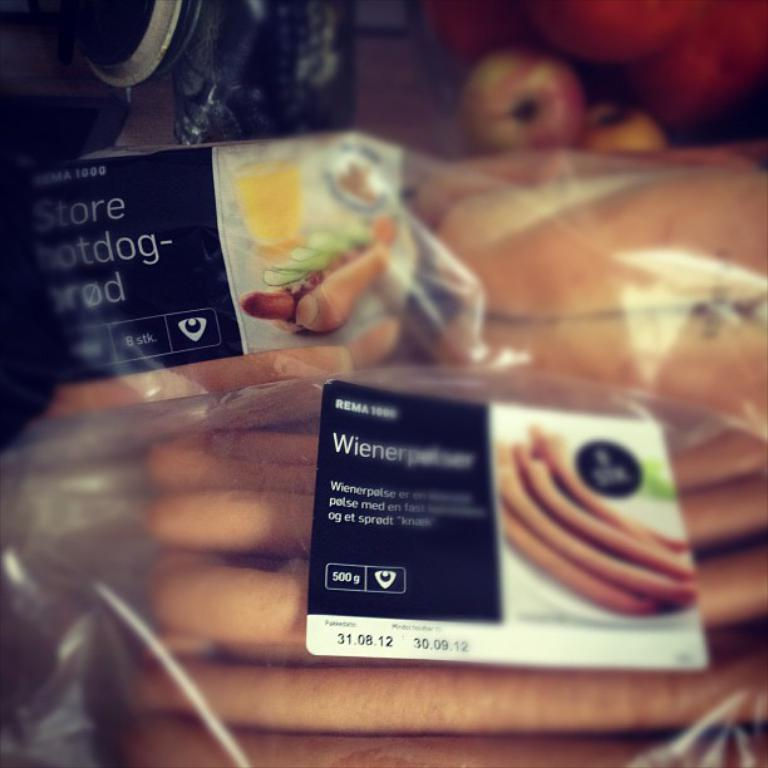What can be seen in the image related to food? There are many food items in the image. How are the food items packaged? The food items are wrapped in a plastic cover. What information is provided on the label in the image? The label mentions apples. What is the condition of the image's edges? The corners of the image are blurred. Reasoning: Let'ing: Let's think step by step in order to produce the conversation. We start by identifying the main subject in the image, which is the food items. Then, we expand the conversation to include details about the packaging and labeling of the food items. We also mention the condition of the image's edges, which is a detail that can be observed directly from the image. Absurd Question/Answer: What type of books can be seen stacked on the marble surface in the image? There are no books or marble surface present in the image; it features food items wrapped in a plastic cover with a label mentioning apples. 